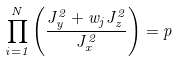<formula> <loc_0><loc_0><loc_500><loc_500>\prod _ { i = 1 } ^ { N } \left ( \frac { J _ { y } ^ { 2 } + w _ { j } J _ { z } ^ { 2 } } { J _ { x } ^ { 2 } } \right ) = p</formula> 